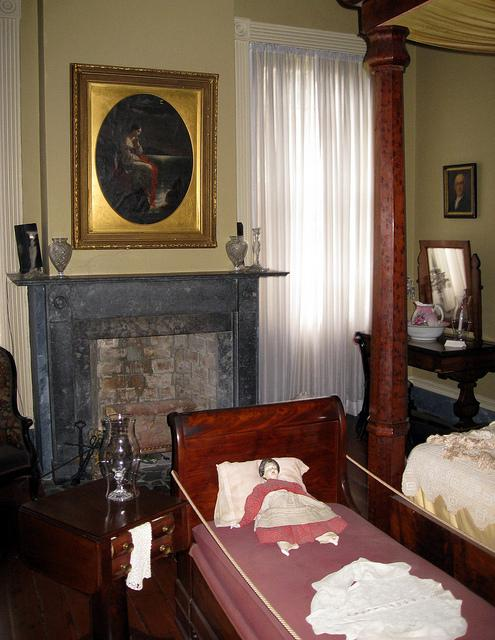What is the black structure against the wall used to contain? fire 